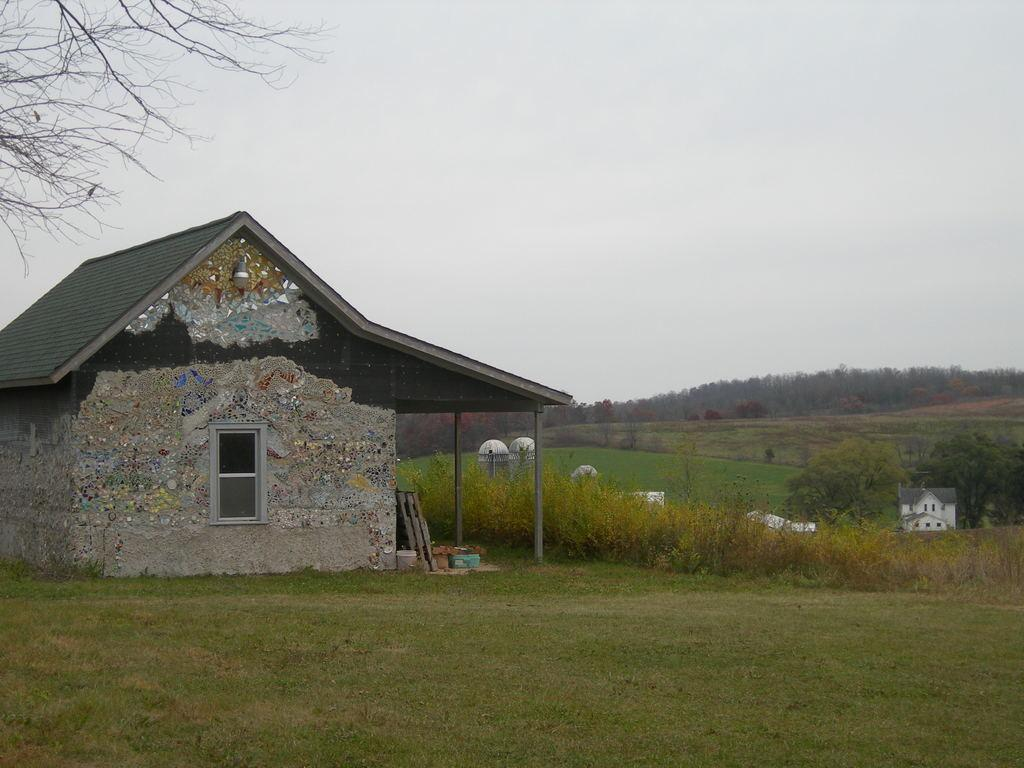What type of structures can be seen in the image? There are buildings in the image. What other natural elements are present in the image? There are plants and trees in the image. What can be seen in the background of the image? The sky is visible in the background of the image. What type of island is visible in the image? There is no island present in the image; it features buildings, plants, trees, and the sky. 